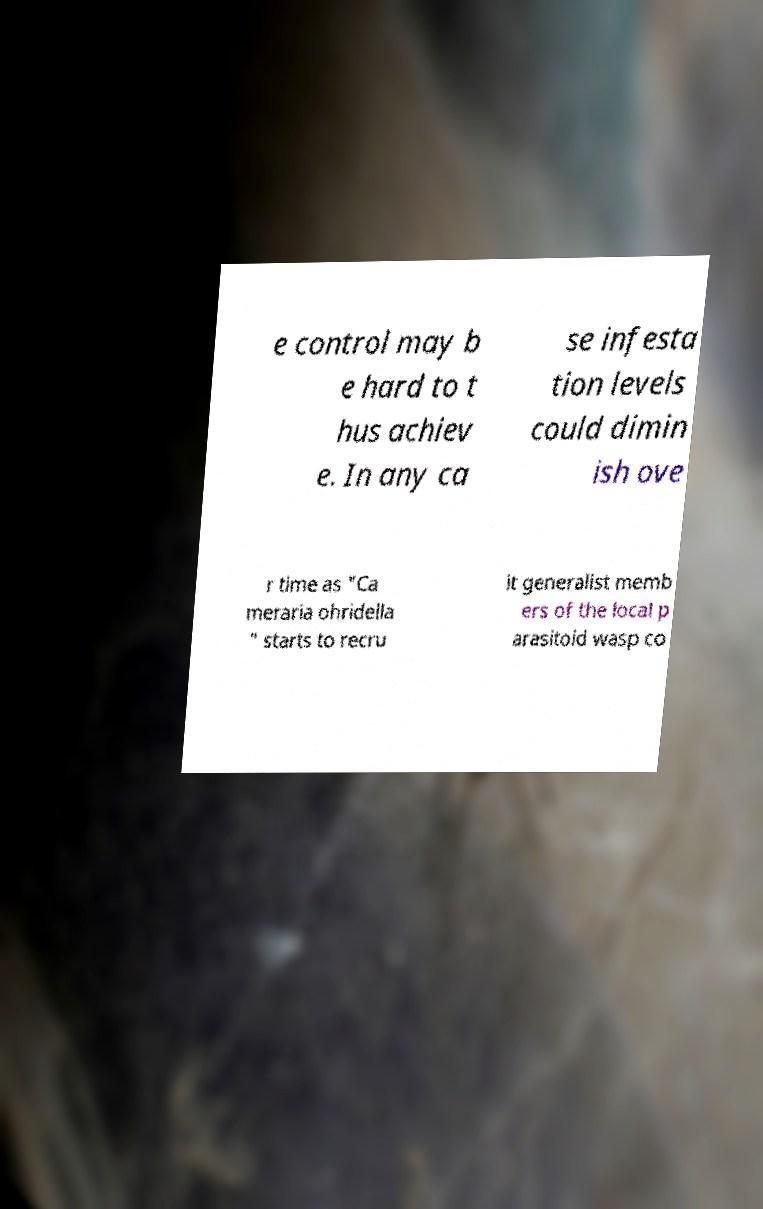Please read and relay the text visible in this image. What does it say? e control may b e hard to t hus achiev e. In any ca se infesta tion levels could dimin ish ove r time as "Ca meraria ohridella " starts to recru it generalist memb ers of the local p arasitoid wasp co 